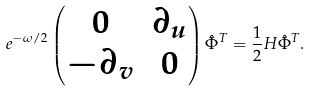Convert formula to latex. <formula><loc_0><loc_0><loc_500><loc_500>e ^ { - \omega / 2 } \begin{pmatrix} 0 & \partial _ { u } \\ - \partial _ { v } & 0 \end{pmatrix} \hat { \Phi } ^ { T } = \frac { 1 } { 2 } H \hat { \Phi } ^ { T } .</formula> 